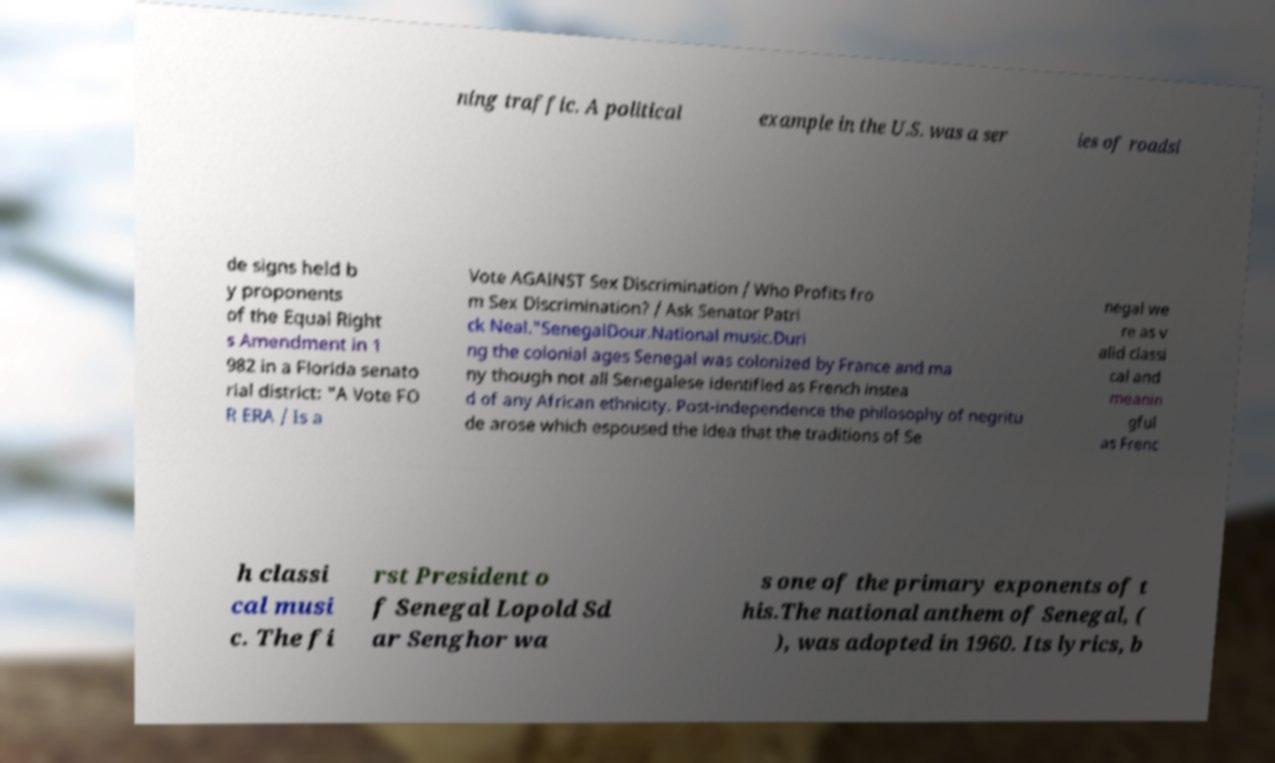Please identify and transcribe the text found in this image. ning traffic. A political example in the U.S. was a ser ies of roadsi de signs held b y proponents of the Equal Right s Amendment in 1 982 in a Florida senato rial district: "A Vote FO R ERA / Is a Vote AGAINST Sex Discrimination / Who Profits fro m Sex Discrimination? / Ask Senator Patri ck Neal."SenegalDour.National music.Duri ng the colonial ages Senegal was colonized by France and ma ny though not all Senegalese identified as French instea d of any African ethnicity. Post-independence the philosophy of negritu de arose which espoused the idea that the traditions of Se negal we re as v alid classi cal and meanin gful as Frenc h classi cal musi c. The fi rst President o f Senegal Lopold Sd ar Senghor wa s one of the primary exponents of t his.The national anthem of Senegal, ( ), was adopted in 1960. Its lyrics, b 